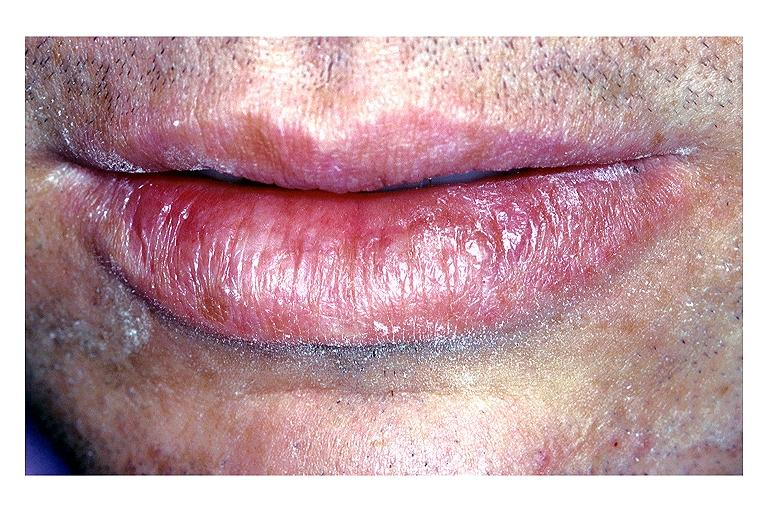does this image show actinic keratosis?
Answer the question using a single word or phrase. Yes 